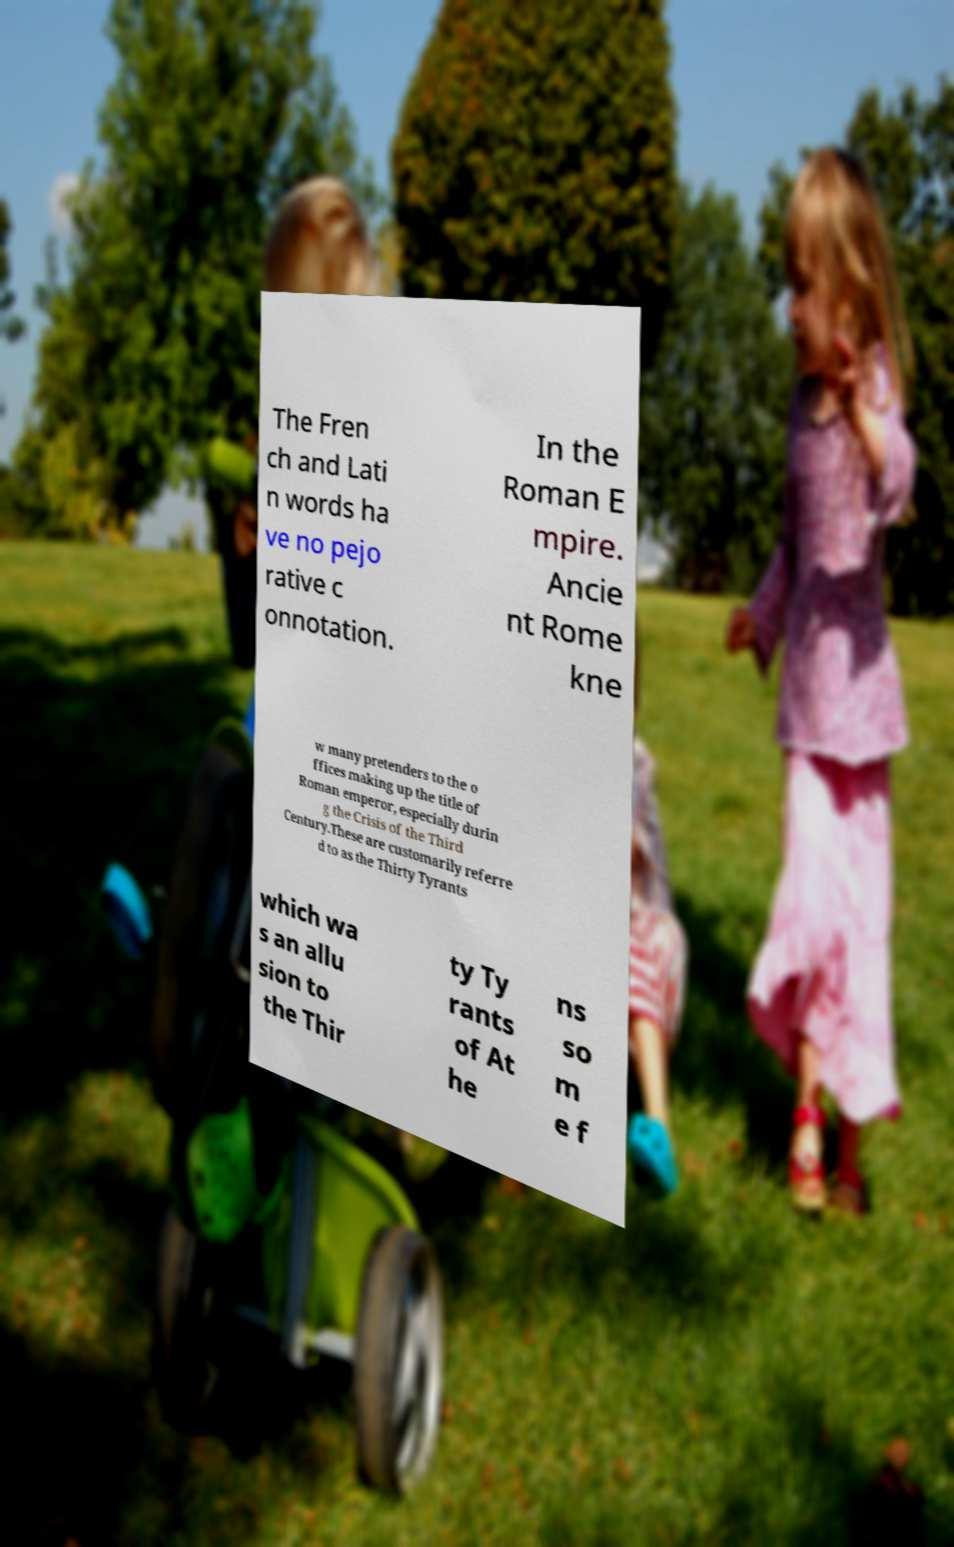Can you accurately transcribe the text from the provided image for me? The Fren ch and Lati n words ha ve no pejo rative c onnotation. In the Roman E mpire. Ancie nt Rome kne w many pretenders to the o ffices making up the title of Roman emperor, especially durin g the Crisis of the Third Century.These are customarily referre d to as the Thirty Tyrants which wa s an allu sion to the Thir ty Ty rants of At he ns so m e f 